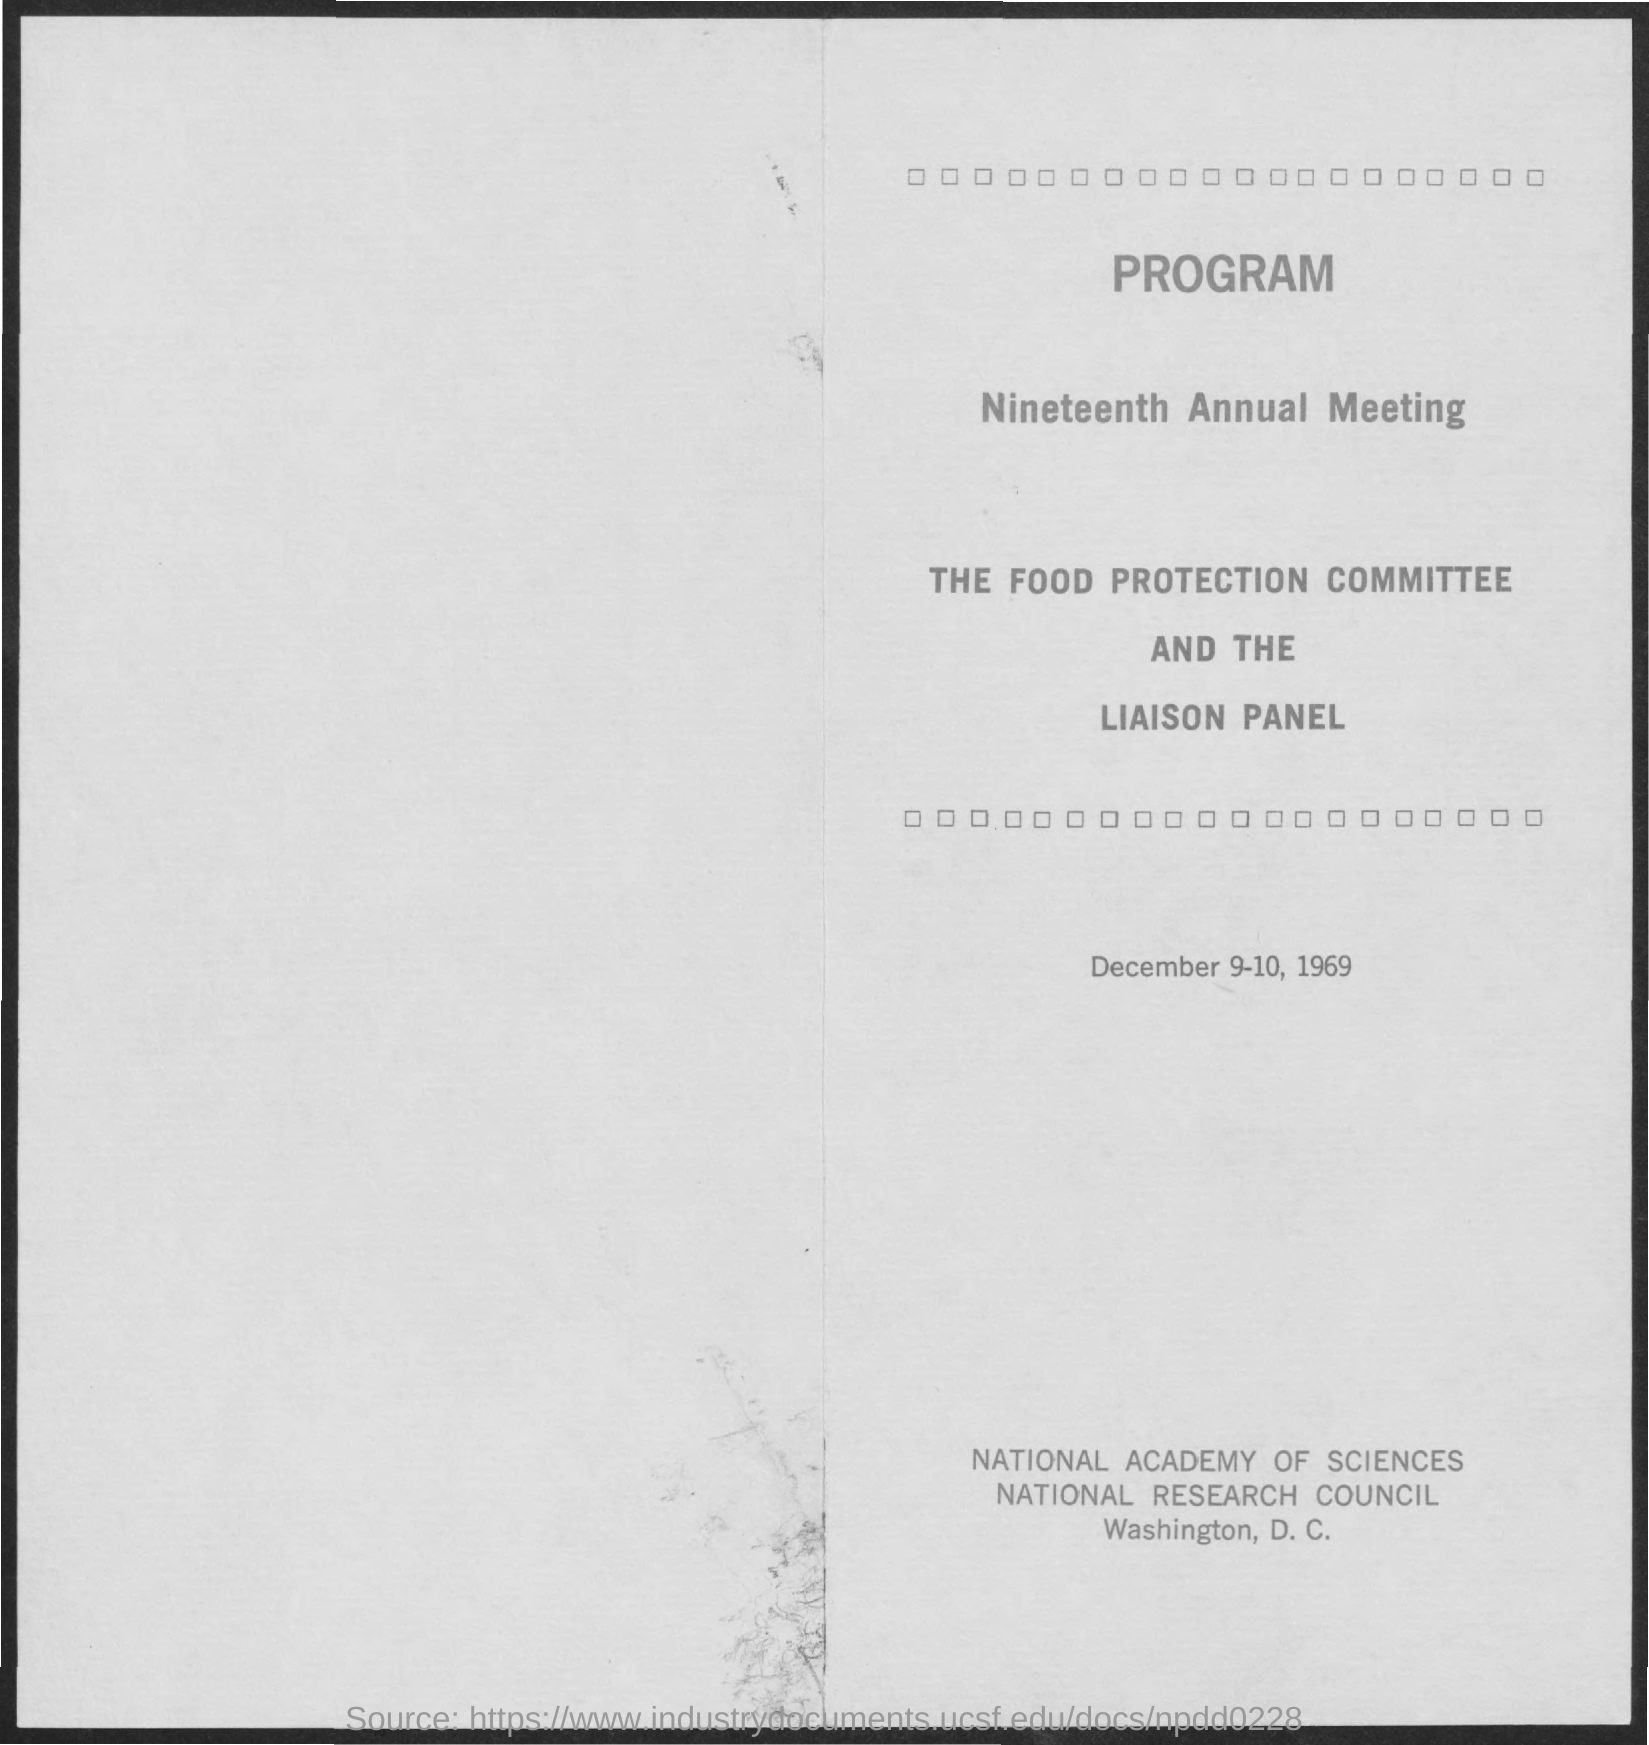What is the second title in the document?
Ensure brevity in your answer.  Nineteenth Annual Meeting. What is the date mentioned in the document?
Offer a terse response. December 9-10, 1969. 